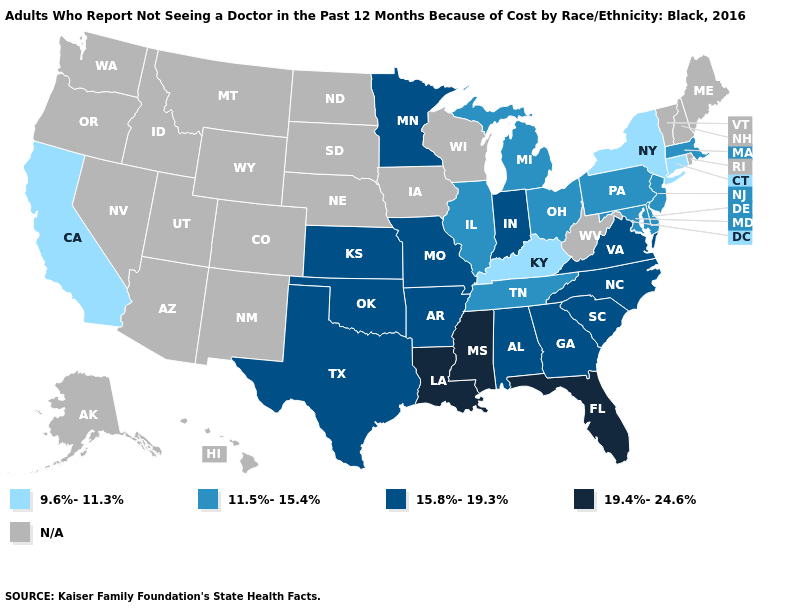Name the states that have a value in the range 19.4%-24.6%?
Concise answer only. Florida, Louisiana, Mississippi. Name the states that have a value in the range N/A?
Keep it brief. Alaska, Arizona, Colorado, Hawaii, Idaho, Iowa, Maine, Montana, Nebraska, Nevada, New Hampshire, New Mexico, North Dakota, Oregon, Rhode Island, South Dakota, Utah, Vermont, Washington, West Virginia, Wisconsin, Wyoming. What is the value of Iowa?
Keep it brief. N/A. Name the states that have a value in the range 15.8%-19.3%?
Keep it brief. Alabama, Arkansas, Georgia, Indiana, Kansas, Minnesota, Missouri, North Carolina, Oklahoma, South Carolina, Texas, Virginia. Name the states that have a value in the range 19.4%-24.6%?
Write a very short answer. Florida, Louisiana, Mississippi. Name the states that have a value in the range N/A?
Answer briefly. Alaska, Arizona, Colorado, Hawaii, Idaho, Iowa, Maine, Montana, Nebraska, Nevada, New Hampshire, New Mexico, North Dakota, Oregon, Rhode Island, South Dakota, Utah, Vermont, Washington, West Virginia, Wisconsin, Wyoming. What is the value of Illinois?
Keep it brief. 11.5%-15.4%. Does Missouri have the lowest value in the MidWest?
Write a very short answer. No. Among the states that border Vermont , does New York have the lowest value?
Concise answer only. Yes. What is the value of Virginia?
Concise answer only. 15.8%-19.3%. Which states have the lowest value in the USA?
Quick response, please. California, Connecticut, Kentucky, New York. Does the map have missing data?
Write a very short answer. Yes. 